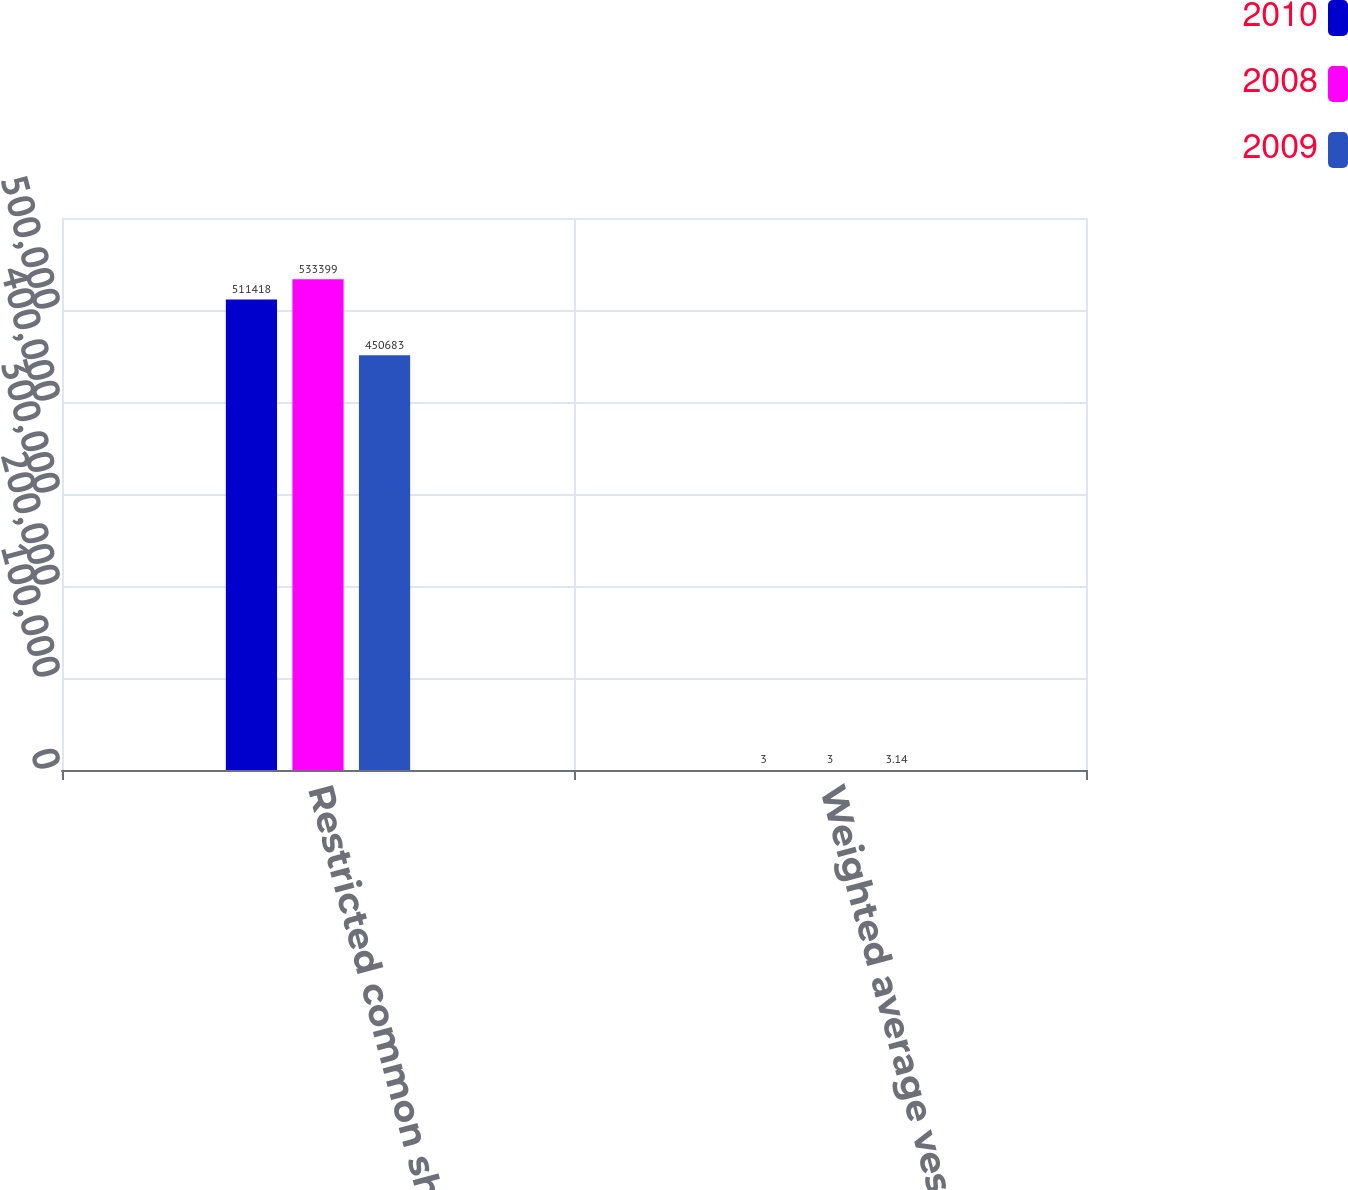<chart> <loc_0><loc_0><loc_500><loc_500><stacked_bar_chart><ecel><fcel>Restricted common shares units<fcel>Weighted average vesting<nl><fcel>2010<fcel>511418<fcel>3<nl><fcel>2008<fcel>533399<fcel>3<nl><fcel>2009<fcel>450683<fcel>3.14<nl></chart> 